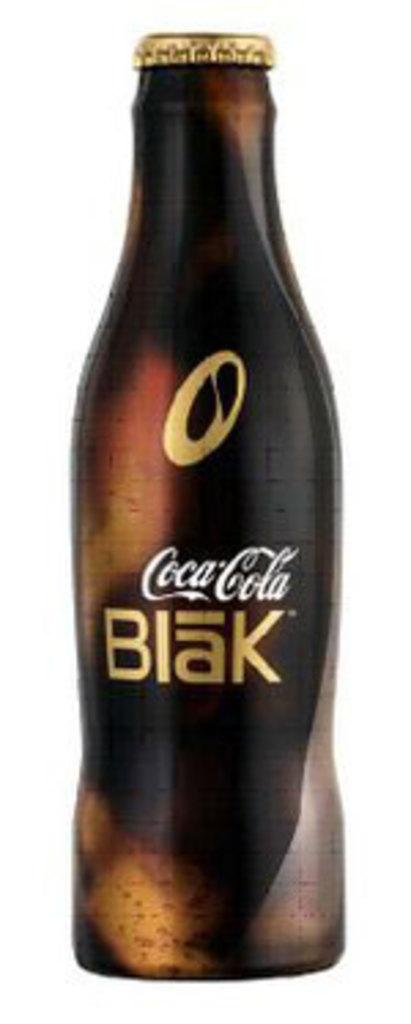Provide a one-sentence caption for the provided image. A bottle of Coca-Cola blak stand alone again a white background. 